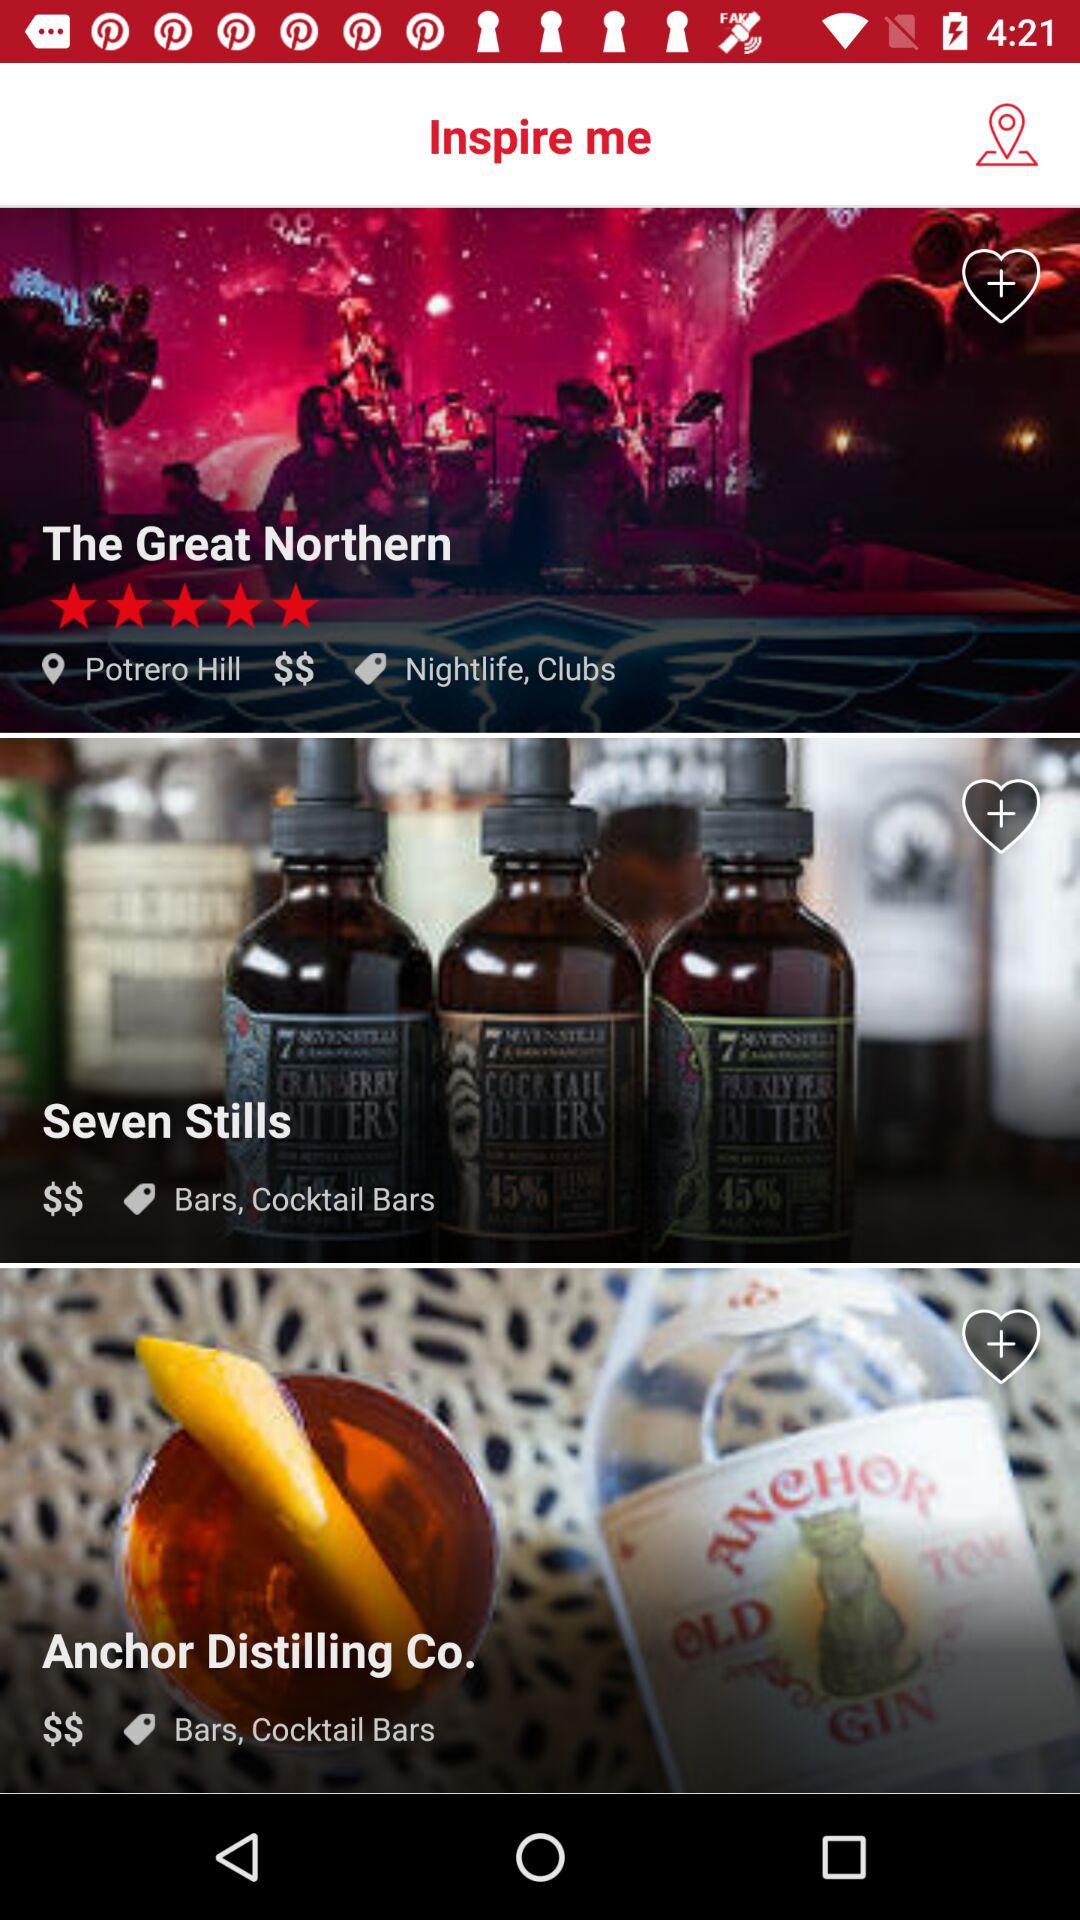How many bars are there in total?
Answer the question using a single word or phrase. 3 